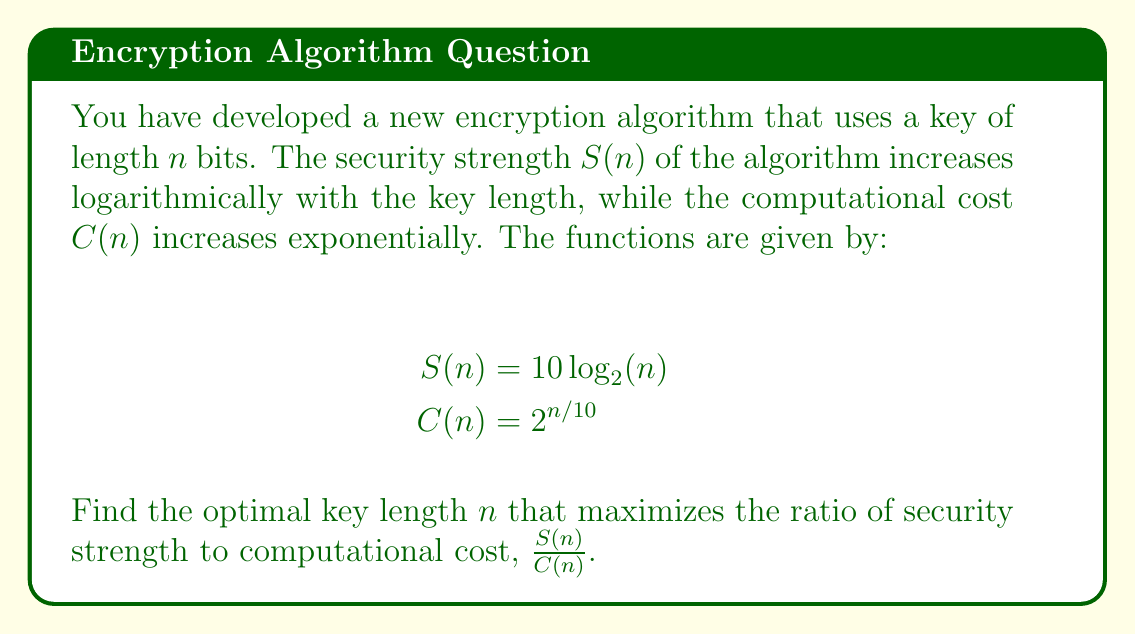Teach me how to tackle this problem. To find the optimal key length, we need to maximize the ratio $\frac{S(n)}{C(n)}$. Let's approach this step-by-step:

1) First, let's define the ratio function $R(n)$:

   $$R(n) = \frac{S(n)}{C(n)} = \frac{10 \log_2(n)}{2^{n/10}}$$

2) To find the maximum of this function, we need to find where its derivative equals zero. Let's calculate the derivative:

   $$R'(n) = \frac{(10 \log_2(n))'(2^{n/10}) - (10 \log_2(n))(2^{n/10})'}{(2^{n/10})^2}$$

3) Simplify the numerator:

   $$R'(n) = \frac{\frac{10}{n \ln(2)} \cdot 2^{n/10} - 10 \log_2(n) \cdot \frac{\ln(2)}{10} \cdot 2^{n/10}}{2^{n/5}}$$

4) Set this equal to zero and simplify:

   $$\frac{10}{n \ln(2)} - \log_2(n) \cdot \frac{\ln(2)}{10} = 0$$

5) Multiply both sides by $n \ln(2)$:

   $$10 - n \cdot (\log_2(n) \cdot \frac{(\ln(2))^2}{10}) = 0$$

6) This equation doesn't have a simple analytical solution. We need to solve it numerically. Using a numerical method (e.g., Newton's method), we find that the solution is approximately:

   $$n \approx 27.18$$

7) Since $n$ must be an integer (as it represents the number of bits), we should check the values of $R(n)$ for $n = 27$ and $n = 28$.

   $$R(27) \approx 0.3674$$
   $$R(28) \approx 0.3675$$

Therefore, the optimal integer value for $n$ is 28.
Answer: The optimal key length is 28 bits. 